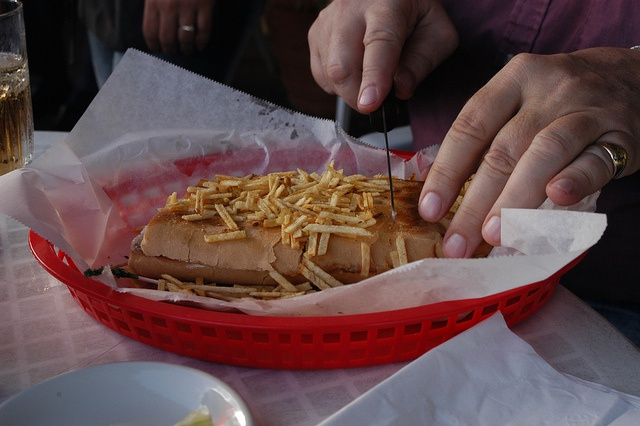Describe the objects in this image and their specific colors. I can see dining table in black, gray, maroon, and darkgray tones, people in black, brown, gray, and maroon tones, sandwich in black, maroon, olive, and gray tones, bowl in black, gray, and darkgray tones, and cup in black, gray, and maroon tones in this image. 